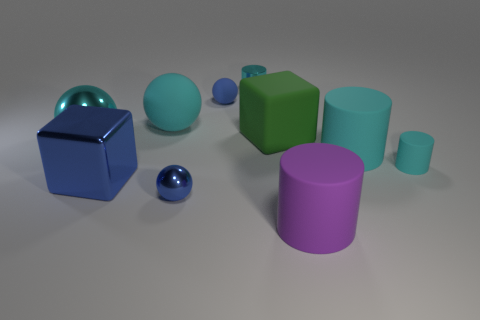What is the material of the tiny cylinder to the right of the large rubber cylinder left of the large object on the right side of the big purple matte object?
Your answer should be compact. Rubber. How many rubber things are big red cylinders or large balls?
Provide a short and direct response. 1. Is there a red cylinder?
Your answer should be very brief. No. There is a small object that is on the right side of the cylinder that is behind the tiny matte sphere; what color is it?
Keep it short and to the point. Cyan. What number of other things are the same color as the big metal ball?
Offer a very short reply. 4. How many things are either cubes or tiny cyan cylinders that are right of the tiny shiny cylinder?
Your answer should be compact. 3. What is the color of the cylinder behind the large green cube?
Provide a succinct answer. Cyan. There is a big purple rubber thing; what shape is it?
Give a very brief answer. Cylinder. What is the material of the large cube that is right of the tiny metal object on the right side of the tiny rubber ball?
Keep it short and to the point. Rubber. What number of other objects are there of the same material as the big cyan cylinder?
Your answer should be compact. 5. 